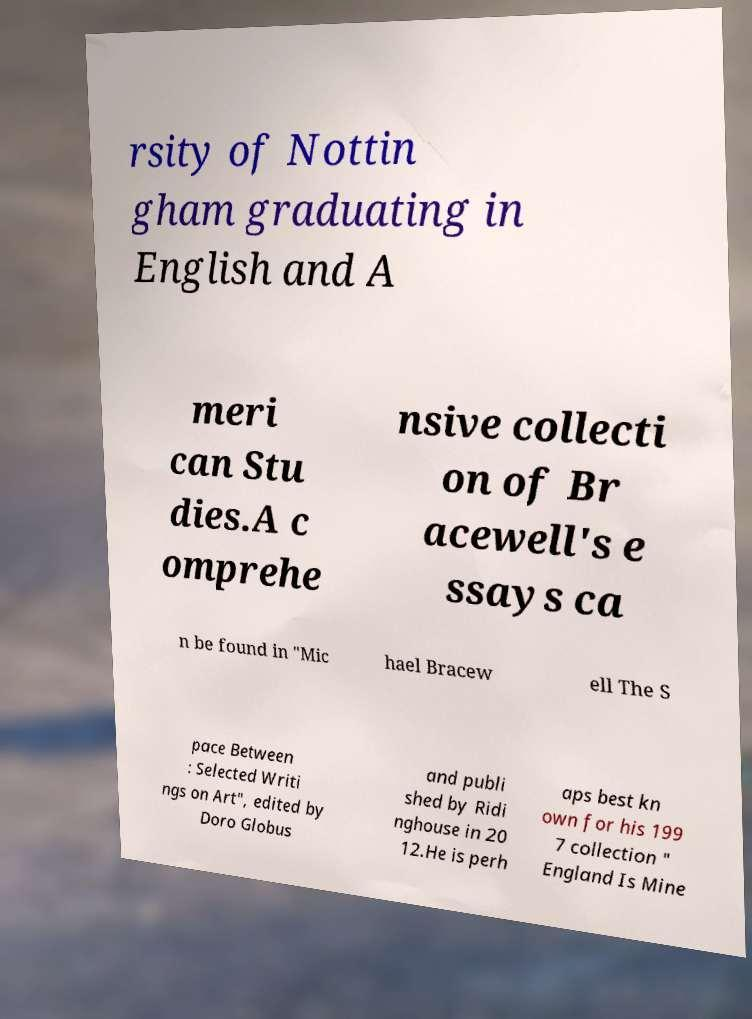Can you accurately transcribe the text from the provided image for me? rsity of Nottin gham graduating in English and A meri can Stu dies.A c omprehe nsive collecti on of Br acewell's e ssays ca n be found in "Mic hael Bracew ell The S pace Between : Selected Writi ngs on Art", edited by Doro Globus and publi shed by Ridi nghouse in 20 12.He is perh aps best kn own for his 199 7 collection " England Is Mine 